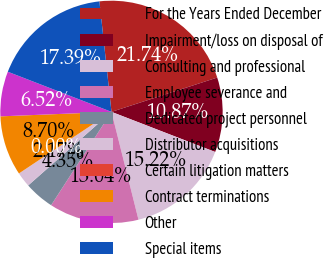Convert chart. <chart><loc_0><loc_0><loc_500><loc_500><pie_chart><fcel>For the Years Ended December<fcel>Impairment/loss on disposal of<fcel>Consulting and professional<fcel>Employee severance and<fcel>Dedicated project personnel<fcel>Distributor acquisitions<fcel>Certain litigation matters<fcel>Contract terminations<fcel>Other<fcel>Special items<nl><fcel>21.74%<fcel>10.87%<fcel>15.22%<fcel>13.04%<fcel>4.35%<fcel>2.17%<fcel>0.0%<fcel>8.7%<fcel>6.52%<fcel>17.39%<nl></chart> 